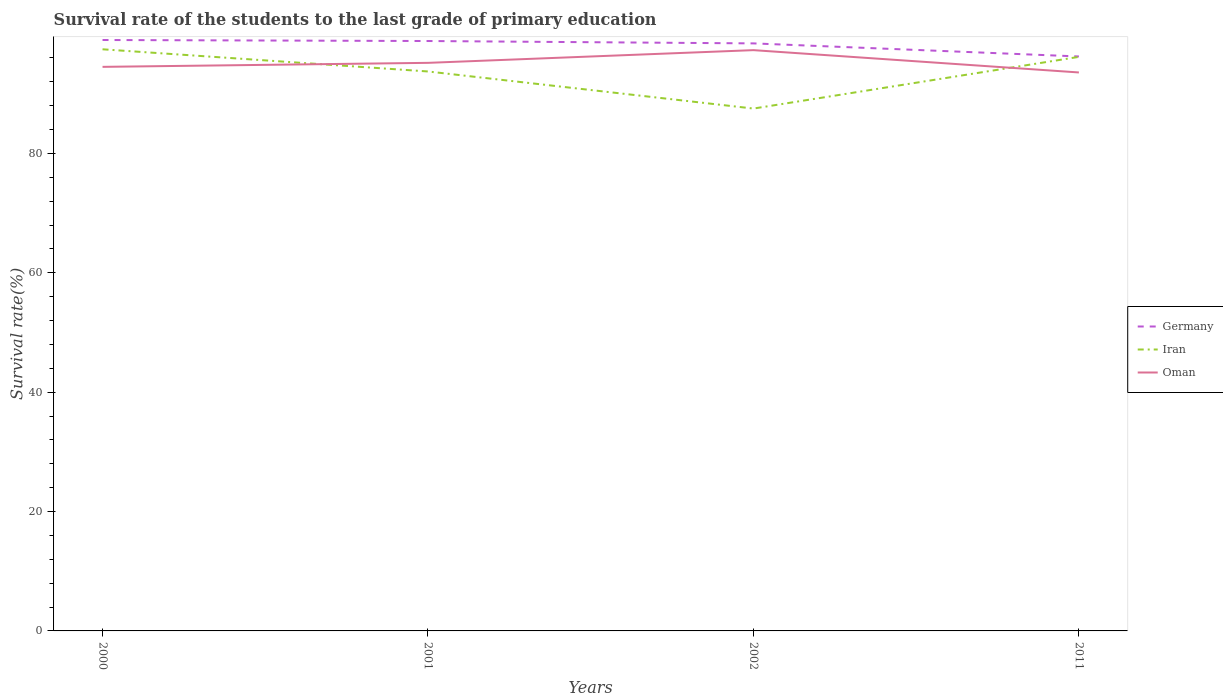Across all years, what is the maximum survival rate of the students in Germany?
Provide a succinct answer. 96.24. What is the total survival rate of the students in Oman in the graph?
Give a very brief answer. -2.8. What is the difference between the highest and the second highest survival rate of the students in Iran?
Your answer should be compact. 9.93. How many lines are there?
Provide a short and direct response. 3. What is the difference between two consecutive major ticks on the Y-axis?
Provide a short and direct response. 20. Are the values on the major ticks of Y-axis written in scientific E-notation?
Your answer should be very brief. No. Does the graph contain grids?
Give a very brief answer. No. What is the title of the graph?
Your answer should be very brief. Survival rate of the students to the last grade of primary education. What is the label or title of the Y-axis?
Your answer should be very brief. Survival rate(%). What is the Survival rate(%) of Germany in 2000?
Offer a very short reply. 99. What is the Survival rate(%) in Iran in 2000?
Ensure brevity in your answer.  97.44. What is the Survival rate(%) of Oman in 2000?
Offer a terse response. 94.5. What is the Survival rate(%) in Germany in 2001?
Provide a short and direct response. 98.83. What is the Survival rate(%) in Iran in 2001?
Your answer should be compact. 93.73. What is the Survival rate(%) in Oman in 2001?
Your response must be concise. 95.17. What is the Survival rate(%) of Germany in 2002?
Make the answer very short. 98.43. What is the Survival rate(%) of Iran in 2002?
Ensure brevity in your answer.  87.52. What is the Survival rate(%) of Oman in 2002?
Keep it short and to the point. 97.3. What is the Survival rate(%) of Germany in 2011?
Offer a very short reply. 96.24. What is the Survival rate(%) in Iran in 2011?
Your answer should be compact. 96.18. What is the Survival rate(%) of Oman in 2011?
Provide a short and direct response. 93.56. Across all years, what is the maximum Survival rate(%) in Germany?
Offer a terse response. 99. Across all years, what is the maximum Survival rate(%) in Iran?
Offer a very short reply. 97.44. Across all years, what is the maximum Survival rate(%) of Oman?
Make the answer very short. 97.3. Across all years, what is the minimum Survival rate(%) of Germany?
Make the answer very short. 96.24. Across all years, what is the minimum Survival rate(%) of Iran?
Give a very brief answer. 87.52. Across all years, what is the minimum Survival rate(%) of Oman?
Provide a short and direct response. 93.56. What is the total Survival rate(%) of Germany in the graph?
Offer a terse response. 392.51. What is the total Survival rate(%) in Iran in the graph?
Provide a short and direct response. 374.87. What is the total Survival rate(%) of Oman in the graph?
Offer a terse response. 380.54. What is the difference between the Survival rate(%) of Germany in 2000 and that in 2001?
Your response must be concise. 0.17. What is the difference between the Survival rate(%) in Iran in 2000 and that in 2001?
Give a very brief answer. 3.71. What is the difference between the Survival rate(%) of Oman in 2000 and that in 2001?
Provide a succinct answer. -0.67. What is the difference between the Survival rate(%) of Germany in 2000 and that in 2002?
Offer a terse response. 0.57. What is the difference between the Survival rate(%) in Iran in 2000 and that in 2002?
Keep it short and to the point. 9.93. What is the difference between the Survival rate(%) of Oman in 2000 and that in 2002?
Provide a succinct answer. -2.8. What is the difference between the Survival rate(%) of Germany in 2000 and that in 2011?
Offer a terse response. 2.76. What is the difference between the Survival rate(%) of Iran in 2000 and that in 2011?
Offer a terse response. 1.27. What is the difference between the Survival rate(%) of Oman in 2000 and that in 2011?
Your answer should be very brief. 0.94. What is the difference between the Survival rate(%) of Germany in 2001 and that in 2002?
Provide a succinct answer. 0.4. What is the difference between the Survival rate(%) of Iran in 2001 and that in 2002?
Your answer should be compact. 6.21. What is the difference between the Survival rate(%) in Oman in 2001 and that in 2002?
Give a very brief answer. -2.13. What is the difference between the Survival rate(%) of Germany in 2001 and that in 2011?
Your response must be concise. 2.59. What is the difference between the Survival rate(%) in Iran in 2001 and that in 2011?
Your answer should be compact. -2.45. What is the difference between the Survival rate(%) of Oman in 2001 and that in 2011?
Give a very brief answer. 1.61. What is the difference between the Survival rate(%) of Germany in 2002 and that in 2011?
Your answer should be compact. 2.19. What is the difference between the Survival rate(%) of Iran in 2002 and that in 2011?
Your answer should be very brief. -8.66. What is the difference between the Survival rate(%) of Oman in 2002 and that in 2011?
Provide a short and direct response. 3.74. What is the difference between the Survival rate(%) of Germany in 2000 and the Survival rate(%) of Iran in 2001?
Provide a succinct answer. 5.27. What is the difference between the Survival rate(%) of Germany in 2000 and the Survival rate(%) of Oman in 2001?
Make the answer very short. 3.83. What is the difference between the Survival rate(%) of Iran in 2000 and the Survival rate(%) of Oman in 2001?
Provide a short and direct response. 2.27. What is the difference between the Survival rate(%) of Germany in 2000 and the Survival rate(%) of Iran in 2002?
Keep it short and to the point. 11.48. What is the difference between the Survival rate(%) of Germany in 2000 and the Survival rate(%) of Oman in 2002?
Ensure brevity in your answer.  1.7. What is the difference between the Survival rate(%) of Iran in 2000 and the Survival rate(%) of Oman in 2002?
Ensure brevity in your answer.  0.14. What is the difference between the Survival rate(%) in Germany in 2000 and the Survival rate(%) in Iran in 2011?
Make the answer very short. 2.83. What is the difference between the Survival rate(%) of Germany in 2000 and the Survival rate(%) of Oman in 2011?
Your answer should be very brief. 5.44. What is the difference between the Survival rate(%) of Iran in 2000 and the Survival rate(%) of Oman in 2011?
Provide a succinct answer. 3.88. What is the difference between the Survival rate(%) of Germany in 2001 and the Survival rate(%) of Iran in 2002?
Offer a terse response. 11.31. What is the difference between the Survival rate(%) in Germany in 2001 and the Survival rate(%) in Oman in 2002?
Offer a terse response. 1.53. What is the difference between the Survival rate(%) of Iran in 2001 and the Survival rate(%) of Oman in 2002?
Make the answer very short. -3.57. What is the difference between the Survival rate(%) in Germany in 2001 and the Survival rate(%) in Iran in 2011?
Your answer should be compact. 2.66. What is the difference between the Survival rate(%) in Germany in 2001 and the Survival rate(%) in Oman in 2011?
Provide a short and direct response. 5.27. What is the difference between the Survival rate(%) in Iran in 2001 and the Survival rate(%) in Oman in 2011?
Provide a short and direct response. 0.17. What is the difference between the Survival rate(%) of Germany in 2002 and the Survival rate(%) of Iran in 2011?
Your answer should be very brief. 2.26. What is the difference between the Survival rate(%) in Germany in 2002 and the Survival rate(%) in Oman in 2011?
Provide a short and direct response. 4.87. What is the difference between the Survival rate(%) of Iran in 2002 and the Survival rate(%) of Oman in 2011?
Ensure brevity in your answer.  -6.05. What is the average Survival rate(%) of Germany per year?
Make the answer very short. 98.13. What is the average Survival rate(%) in Iran per year?
Your response must be concise. 93.72. What is the average Survival rate(%) of Oman per year?
Your answer should be very brief. 95.14. In the year 2000, what is the difference between the Survival rate(%) of Germany and Survival rate(%) of Iran?
Make the answer very short. 1.56. In the year 2000, what is the difference between the Survival rate(%) in Germany and Survival rate(%) in Oman?
Provide a short and direct response. 4.5. In the year 2000, what is the difference between the Survival rate(%) of Iran and Survival rate(%) of Oman?
Your answer should be very brief. 2.94. In the year 2001, what is the difference between the Survival rate(%) in Germany and Survival rate(%) in Iran?
Keep it short and to the point. 5.1. In the year 2001, what is the difference between the Survival rate(%) of Germany and Survival rate(%) of Oman?
Your answer should be compact. 3.66. In the year 2001, what is the difference between the Survival rate(%) in Iran and Survival rate(%) in Oman?
Give a very brief answer. -1.44. In the year 2002, what is the difference between the Survival rate(%) of Germany and Survival rate(%) of Iran?
Ensure brevity in your answer.  10.92. In the year 2002, what is the difference between the Survival rate(%) in Germany and Survival rate(%) in Oman?
Keep it short and to the point. 1.13. In the year 2002, what is the difference between the Survival rate(%) in Iran and Survival rate(%) in Oman?
Provide a succinct answer. -9.79. In the year 2011, what is the difference between the Survival rate(%) of Germany and Survival rate(%) of Iran?
Keep it short and to the point. 0.07. In the year 2011, what is the difference between the Survival rate(%) of Germany and Survival rate(%) of Oman?
Ensure brevity in your answer.  2.68. In the year 2011, what is the difference between the Survival rate(%) in Iran and Survival rate(%) in Oman?
Your response must be concise. 2.61. What is the ratio of the Survival rate(%) in Iran in 2000 to that in 2001?
Make the answer very short. 1.04. What is the ratio of the Survival rate(%) of Oman in 2000 to that in 2001?
Your response must be concise. 0.99. What is the ratio of the Survival rate(%) in Iran in 2000 to that in 2002?
Offer a terse response. 1.11. What is the ratio of the Survival rate(%) in Oman in 2000 to that in 2002?
Provide a short and direct response. 0.97. What is the ratio of the Survival rate(%) of Germany in 2000 to that in 2011?
Keep it short and to the point. 1.03. What is the ratio of the Survival rate(%) of Iran in 2000 to that in 2011?
Your answer should be compact. 1.01. What is the ratio of the Survival rate(%) in Iran in 2001 to that in 2002?
Your answer should be very brief. 1.07. What is the ratio of the Survival rate(%) of Oman in 2001 to that in 2002?
Give a very brief answer. 0.98. What is the ratio of the Survival rate(%) in Germany in 2001 to that in 2011?
Provide a succinct answer. 1.03. What is the ratio of the Survival rate(%) in Iran in 2001 to that in 2011?
Give a very brief answer. 0.97. What is the ratio of the Survival rate(%) in Oman in 2001 to that in 2011?
Provide a short and direct response. 1.02. What is the ratio of the Survival rate(%) of Germany in 2002 to that in 2011?
Ensure brevity in your answer.  1.02. What is the ratio of the Survival rate(%) of Iran in 2002 to that in 2011?
Your answer should be compact. 0.91. What is the difference between the highest and the second highest Survival rate(%) in Germany?
Offer a very short reply. 0.17. What is the difference between the highest and the second highest Survival rate(%) in Iran?
Give a very brief answer. 1.27. What is the difference between the highest and the second highest Survival rate(%) in Oman?
Offer a very short reply. 2.13. What is the difference between the highest and the lowest Survival rate(%) of Germany?
Ensure brevity in your answer.  2.76. What is the difference between the highest and the lowest Survival rate(%) of Iran?
Ensure brevity in your answer.  9.93. What is the difference between the highest and the lowest Survival rate(%) of Oman?
Make the answer very short. 3.74. 